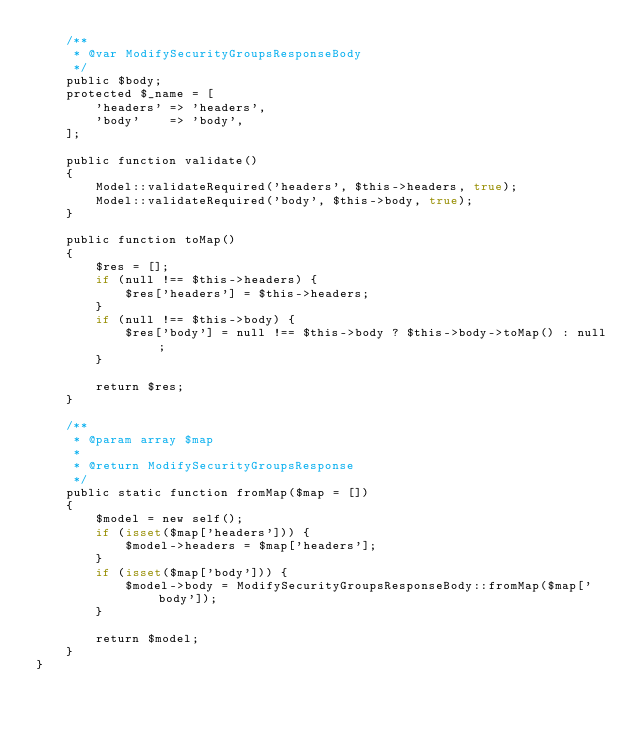<code> <loc_0><loc_0><loc_500><loc_500><_PHP_>    /**
     * @var ModifySecurityGroupsResponseBody
     */
    public $body;
    protected $_name = [
        'headers' => 'headers',
        'body'    => 'body',
    ];

    public function validate()
    {
        Model::validateRequired('headers', $this->headers, true);
        Model::validateRequired('body', $this->body, true);
    }

    public function toMap()
    {
        $res = [];
        if (null !== $this->headers) {
            $res['headers'] = $this->headers;
        }
        if (null !== $this->body) {
            $res['body'] = null !== $this->body ? $this->body->toMap() : null;
        }

        return $res;
    }

    /**
     * @param array $map
     *
     * @return ModifySecurityGroupsResponse
     */
    public static function fromMap($map = [])
    {
        $model = new self();
        if (isset($map['headers'])) {
            $model->headers = $map['headers'];
        }
        if (isset($map['body'])) {
            $model->body = ModifySecurityGroupsResponseBody::fromMap($map['body']);
        }

        return $model;
    }
}
</code> 